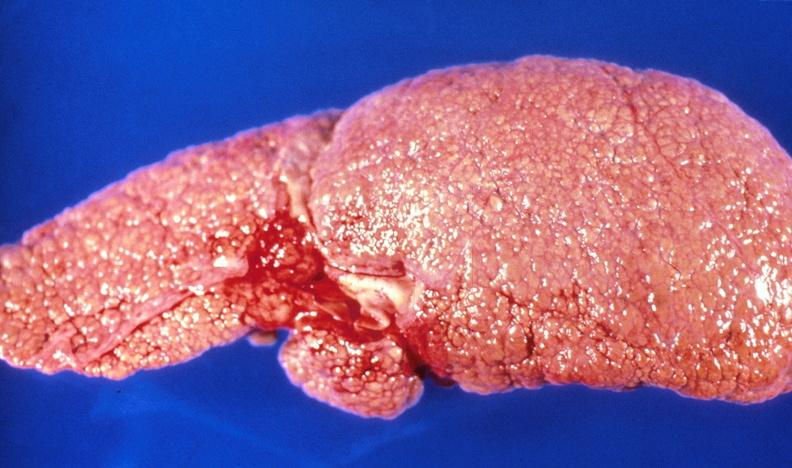what is present?
Answer the question using a single word or phrase. Liver 